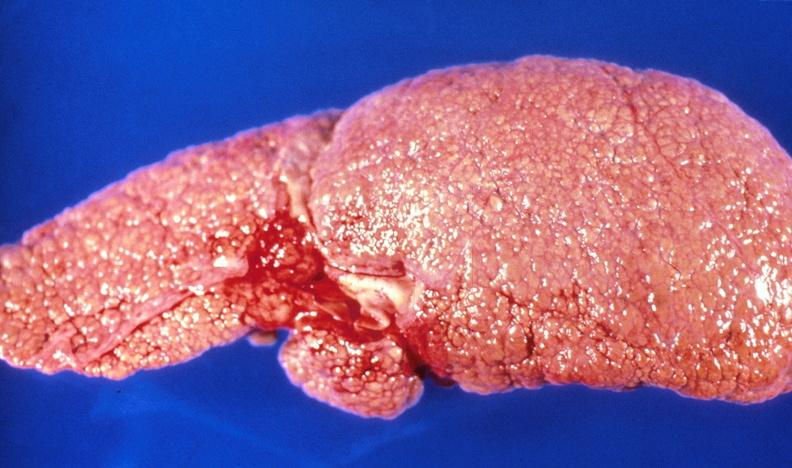what is present?
Answer the question using a single word or phrase. Liver 